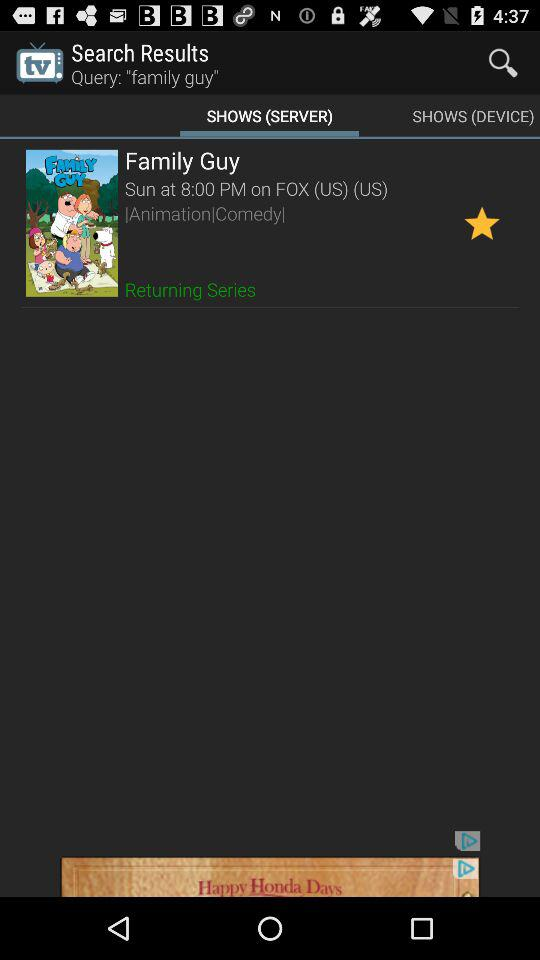Which type of show is "Family Guy"? "Family Guy" is an animation and comedy show. 